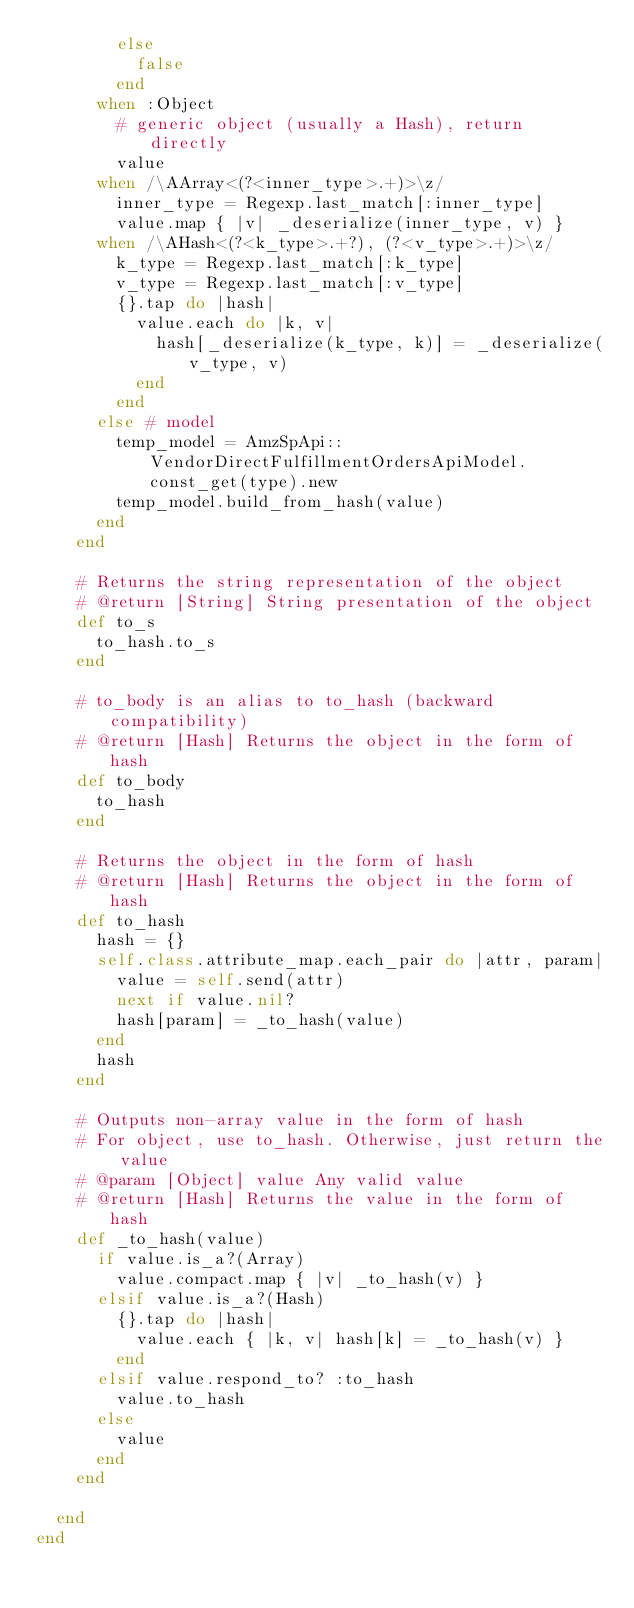Convert code to text. <code><loc_0><loc_0><loc_500><loc_500><_Ruby_>        else
          false
        end
      when :Object
        # generic object (usually a Hash), return directly
        value
      when /\AArray<(?<inner_type>.+)>\z/
        inner_type = Regexp.last_match[:inner_type]
        value.map { |v| _deserialize(inner_type, v) }
      when /\AHash<(?<k_type>.+?), (?<v_type>.+)>\z/
        k_type = Regexp.last_match[:k_type]
        v_type = Regexp.last_match[:v_type]
        {}.tap do |hash|
          value.each do |k, v|
            hash[_deserialize(k_type, k)] = _deserialize(v_type, v)
          end
        end
      else # model
        temp_model = AmzSpApi::VendorDirectFulfillmentOrdersApiModel.const_get(type).new
        temp_model.build_from_hash(value)
      end
    end

    # Returns the string representation of the object
    # @return [String] String presentation of the object
    def to_s
      to_hash.to_s
    end

    # to_body is an alias to to_hash (backward compatibility)
    # @return [Hash] Returns the object in the form of hash
    def to_body
      to_hash
    end

    # Returns the object in the form of hash
    # @return [Hash] Returns the object in the form of hash
    def to_hash
      hash = {}
      self.class.attribute_map.each_pair do |attr, param|
        value = self.send(attr)
        next if value.nil?
        hash[param] = _to_hash(value)
      end
      hash
    end

    # Outputs non-array value in the form of hash
    # For object, use to_hash. Otherwise, just return the value
    # @param [Object] value Any valid value
    # @return [Hash] Returns the value in the form of hash
    def _to_hash(value)
      if value.is_a?(Array)
        value.compact.map { |v| _to_hash(v) }
      elsif value.is_a?(Hash)
        {}.tap do |hash|
          value.each { |k, v| hash[k] = _to_hash(v) }
        end
      elsif value.respond_to? :to_hash
        value.to_hash
      else
        value
      end
    end

  end
end
</code> 